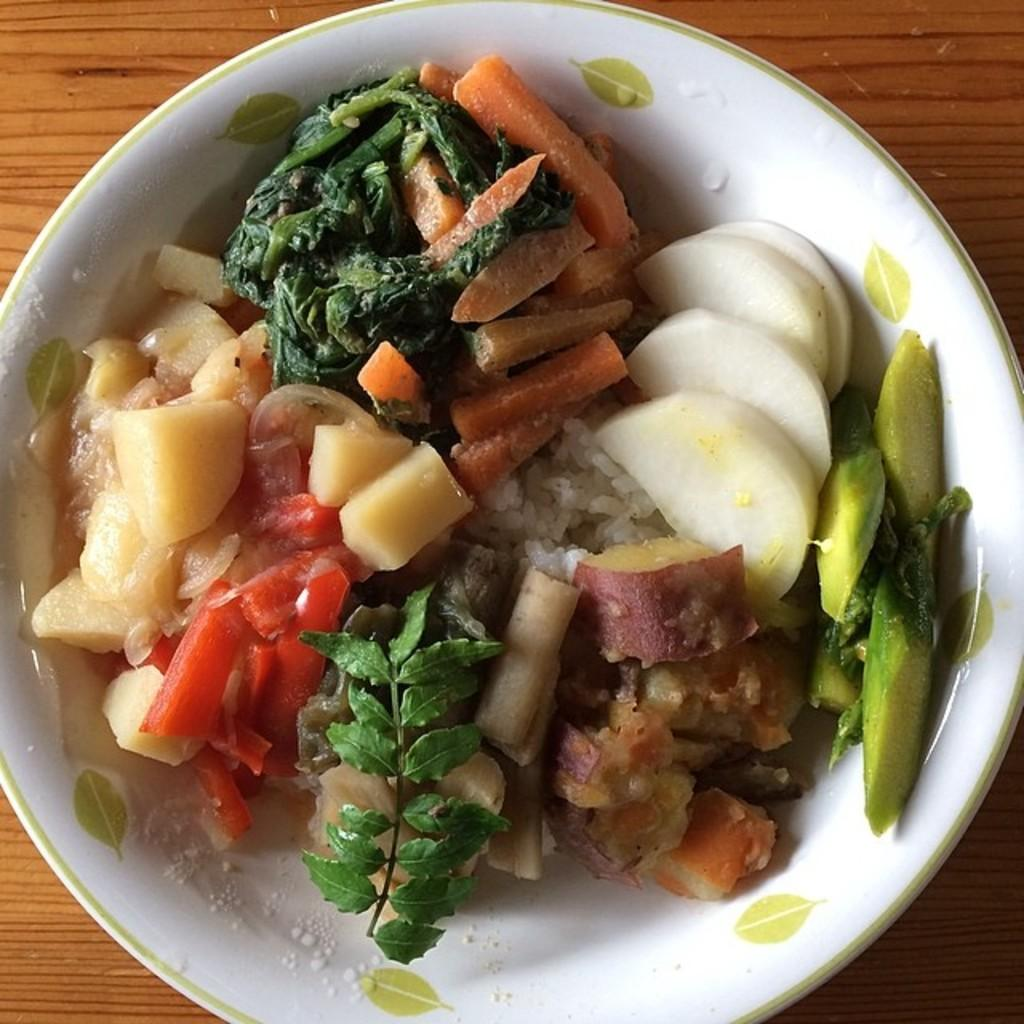What is the main object in the center of the image? There is a white color palette in the center of the image. What is on the palette? The palette contains food items. What type of surface can be seen in the background of the image? There is a wooden object in the background of the image, which seems to be a table. What is the value of the coal in the image? There is no coal present in the image, so it is not possible to determine its value. 